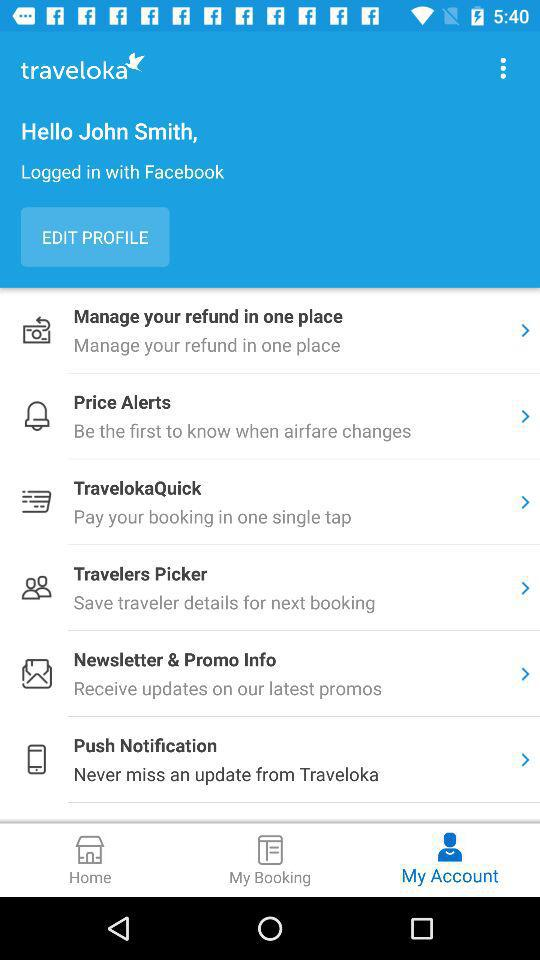Which tab is selected? The selected tab is "My Account". 